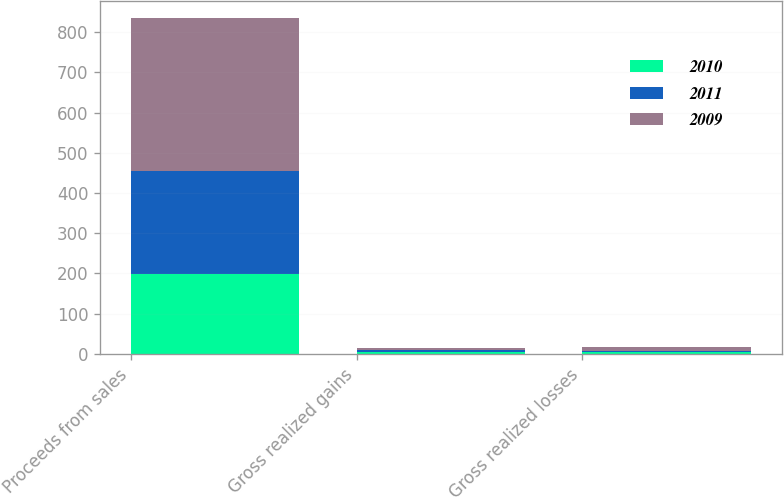<chart> <loc_0><loc_0><loc_500><loc_500><stacked_bar_chart><ecel><fcel>Proceeds from sales<fcel>Gross realized gains<fcel>Gross realized losses<nl><fcel>2010<fcel>199<fcel>5<fcel>4<nl><fcel>2011<fcel>256<fcel>5<fcel>4<nl><fcel>2009<fcel>380<fcel>5<fcel>10<nl></chart> 